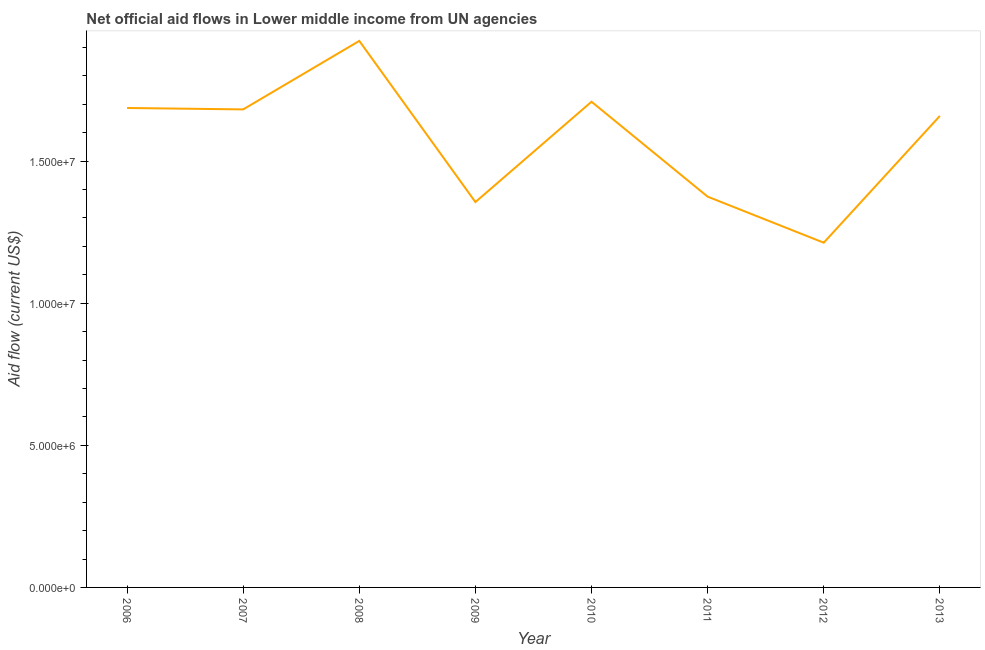What is the net official flows from un agencies in 2013?
Give a very brief answer. 1.66e+07. Across all years, what is the maximum net official flows from un agencies?
Your response must be concise. 1.92e+07. Across all years, what is the minimum net official flows from un agencies?
Your response must be concise. 1.21e+07. In which year was the net official flows from un agencies maximum?
Make the answer very short. 2008. In which year was the net official flows from un agencies minimum?
Make the answer very short. 2012. What is the sum of the net official flows from un agencies?
Provide a succinct answer. 1.26e+08. What is the difference between the net official flows from un agencies in 2010 and 2012?
Offer a very short reply. 4.96e+06. What is the average net official flows from un agencies per year?
Your response must be concise. 1.58e+07. What is the median net official flows from un agencies?
Provide a succinct answer. 1.67e+07. Do a majority of the years between 2013 and 2008 (inclusive) have net official flows from un agencies greater than 16000000 US$?
Keep it short and to the point. Yes. What is the ratio of the net official flows from un agencies in 2008 to that in 2009?
Offer a terse response. 1.42. What is the difference between the highest and the second highest net official flows from un agencies?
Give a very brief answer. 2.14e+06. Is the sum of the net official flows from un agencies in 2006 and 2011 greater than the maximum net official flows from un agencies across all years?
Provide a short and direct response. Yes. What is the difference between the highest and the lowest net official flows from un agencies?
Provide a succinct answer. 7.10e+06. In how many years, is the net official flows from un agencies greater than the average net official flows from un agencies taken over all years?
Provide a succinct answer. 5. Does the net official flows from un agencies monotonically increase over the years?
Keep it short and to the point. No. What is the difference between two consecutive major ticks on the Y-axis?
Provide a succinct answer. 5.00e+06. Are the values on the major ticks of Y-axis written in scientific E-notation?
Offer a very short reply. Yes. Does the graph contain grids?
Make the answer very short. No. What is the title of the graph?
Keep it short and to the point. Net official aid flows in Lower middle income from UN agencies. What is the Aid flow (current US$) in 2006?
Give a very brief answer. 1.69e+07. What is the Aid flow (current US$) of 2007?
Provide a succinct answer. 1.68e+07. What is the Aid flow (current US$) of 2008?
Give a very brief answer. 1.92e+07. What is the Aid flow (current US$) in 2009?
Ensure brevity in your answer.  1.36e+07. What is the Aid flow (current US$) of 2010?
Ensure brevity in your answer.  1.71e+07. What is the Aid flow (current US$) in 2011?
Give a very brief answer. 1.38e+07. What is the Aid flow (current US$) of 2012?
Offer a terse response. 1.21e+07. What is the Aid flow (current US$) of 2013?
Keep it short and to the point. 1.66e+07. What is the difference between the Aid flow (current US$) in 2006 and 2008?
Ensure brevity in your answer.  -2.36e+06. What is the difference between the Aid flow (current US$) in 2006 and 2009?
Provide a succinct answer. 3.31e+06. What is the difference between the Aid flow (current US$) in 2006 and 2011?
Your answer should be very brief. 3.12e+06. What is the difference between the Aid flow (current US$) in 2006 and 2012?
Provide a short and direct response. 4.74e+06. What is the difference between the Aid flow (current US$) in 2007 and 2008?
Your answer should be compact. -2.41e+06. What is the difference between the Aid flow (current US$) in 2007 and 2009?
Make the answer very short. 3.26e+06. What is the difference between the Aid flow (current US$) in 2007 and 2010?
Your response must be concise. -2.70e+05. What is the difference between the Aid flow (current US$) in 2007 and 2011?
Offer a very short reply. 3.07e+06. What is the difference between the Aid flow (current US$) in 2007 and 2012?
Provide a succinct answer. 4.69e+06. What is the difference between the Aid flow (current US$) in 2008 and 2009?
Provide a short and direct response. 5.67e+06. What is the difference between the Aid flow (current US$) in 2008 and 2010?
Ensure brevity in your answer.  2.14e+06. What is the difference between the Aid flow (current US$) in 2008 and 2011?
Your response must be concise. 5.48e+06. What is the difference between the Aid flow (current US$) in 2008 and 2012?
Offer a very short reply. 7.10e+06. What is the difference between the Aid flow (current US$) in 2008 and 2013?
Offer a very short reply. 2.64e+06. What is the difference between the Aid flow (current US$) in 2009 and 2010?
Provide a short and direct response. -3.53e+06. What is the difference between the Aid flow (current US$) in 2009 and 2011?
Give a very brief answer. -1.90e+05. What is the difference between the Aid flow (current US$) in 2009 and 2012?
Keep it short and to the point. 1.43e+06. What is the difference between the Aid flow (current US$) in 2009 and 2013?
Your answer should be compact. -3.03e+06. What is the difference between the Aid flow (current US$) in 2010 and 2011?
Provide a short and direct response. 3.34e+06. What is the difference between the Aid flow (current US$) in 2010 and 2012?
Make the answer very short. 4.96e+06. What is the difference between the Aid flow (current US$) in 2011 and 2012?
Your answer should be very brief. 1.62e+06. What is the difference between the Aid flow (current US$) in 2011 and 2013?
Your answer should be compact. -2.84e+06. What is the difference between the Aid flow (current US$) in 2012 and 2013?
Offer a very short reply. -4.46e+06. What is the ratio of the Aid flow (current US$) in 2006 to that in 2007?
Offer a very short reply. 1. What is the ratio of the Aid flow (current US$) in 2006 to that in 2008?
Offer a terse response. 0.88. What is the ratio of the Aid flow (current US$) in 2006 to that in 2009?
Offer a very short reply. 1.24. What is the ratio of the Aid flow (current US$) in 2006 to that in 2011?
Provide a short and direct response. 1.23. What is the ratio of the Aid flow (current US$) in 2006 to that in 2012?
Make the answer very short. 1.39. What is the ratio of the Aid flow (current US$) in 2006 to that in 2013?
Make the answer very short. 1.02. What is the ratio of the Aid flow (current US$) in 2007 to that in 2009?
Offer a terse response. 1.24. What is the ratio of the Aid flow (current US$) in 2007 to that in 2011?
Give a very brief answer. 1.22. What is the ratio of the Aid flow (current US$) in 2007 to that in 2012?
Your answer should be very brief. 1.39. What is the ratio of the Aid flow (current US$) in 2008 to that in 2009?
Give a very brief answer. 1.42. What is the ratio of the Aid flow (current US$) in 2008 to that in 2011?
Your response must be concise. 1.4. What is the ratio of the Aid flow (current US$) in 2008 to that in 2012?
Ensure brevity in your answer.  1.58. What is the ratio of the Aid flow (current US$) in 2008 to that in 2013?
Offer a very short reply. 1.16. What is the ratio of the Aid flow (current US$) in 2009 to that in 2010?
Give a very brief answer. 0.79. What is the ratio of the Aid flow (current US$) in 2009 to that in 2012?
Make the answer very short. 1.12. What is the ratio of the Aid flow (current US$) in 2009 to that in 2013?
Your answer should be compact. 0.82. What is the ratio of the Aid flow (current US$) in 2010 to that in 2011?
Offer a terse response. 1.24. What is the ratio of the Aid flow (current US$) in 2010 to that in 2012?
Provide a short and direct response. 1.41. What is the ratio of the Aid flow (current US$) in 2010 to that in 2013?
Offer a terse response. 1.03. What is the ratio of the Aid flow (current US$) in 2011 to that in 2012?
Your answer should be very brief. 1.13. What is the ratio of the Aid flow (current US$) in 2011 to that in 2013?
Provide a succinct answer. 0.83. What is the ratio of the Aid flow (current US$) in 2012 to that in 2013?
Ensure brevity in your answer.  0.73. 